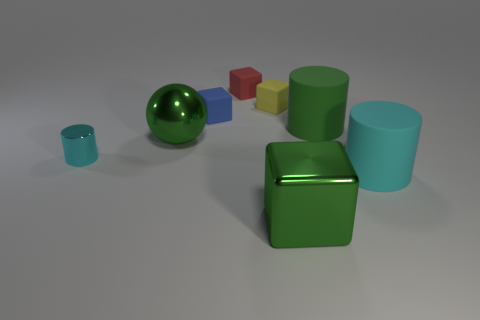The large sphere has what color?
Your answer should be very brief. Green. Are there fewer small cyan cylinders behind the tiny blue thing than green things that are on the left side of the large green matte cylinder?
Offer a very short reply. Yes. There is a rubber thing that is both left of the yellow object and in front of the tiny red rubber object; what shape is it?
Your response must be concise. Cube. How many other cyan things have the same shape as the cyan rubber object?
Offer a very short reply. 1. What size is the cyan cylinder that is made of the same material as the tiny red cube?
Your answer should be compact. Large. How many yellow metallic spheres are the same size as the blue matte object?
Keep it short and to the point. 0. There is a large rubber cylinder that is on the right side of the cylinder behind the ball; what is its color?
Provide a short and direct response. Cyan. Are there any things of the same color as the tiny cylinder?
Your answer should be compact. Yes. The matte object that is the same size as the green rubber cylinder is what color?
Give a very brief answer. Cyan. Does the big thing that is left of the small red matte block have the same material as the blue object?
Give a very brief answer. No. 